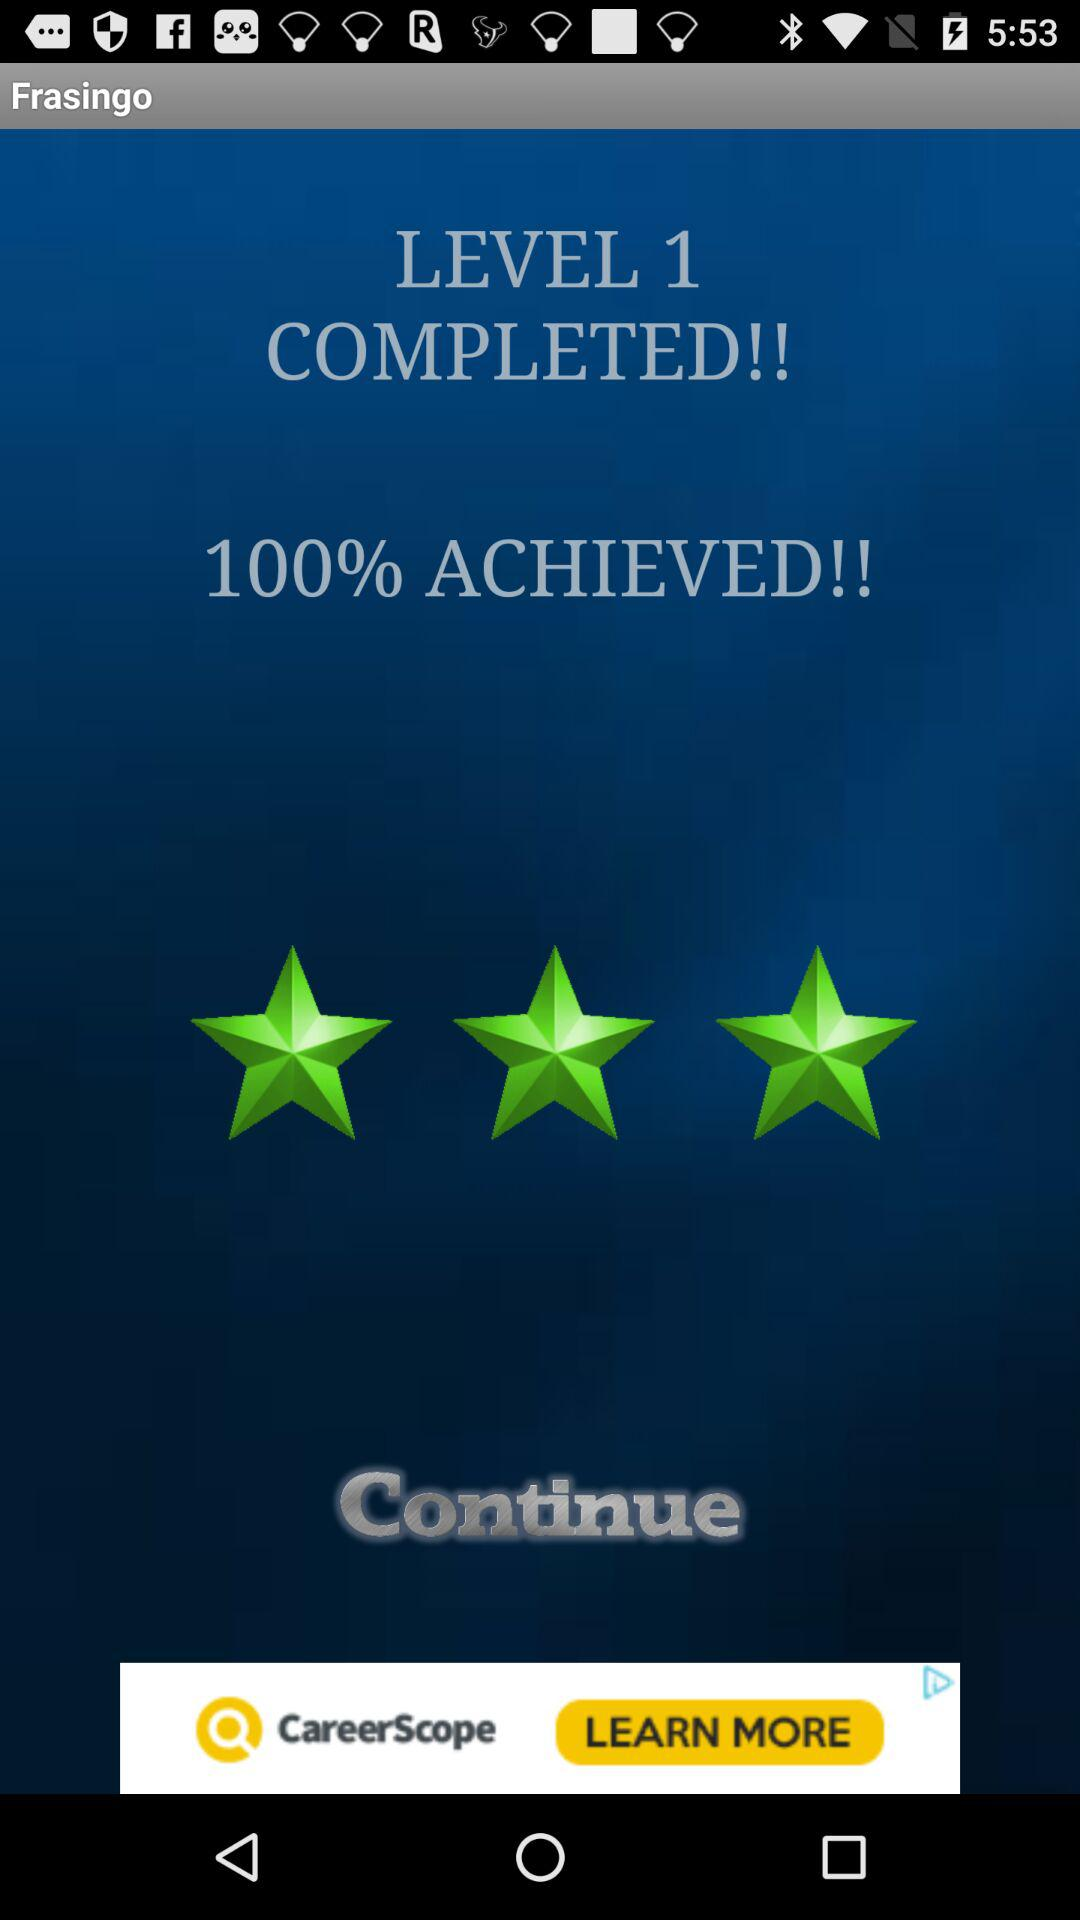What percentage is achieved at level 1? The achieved percentage is 100. 